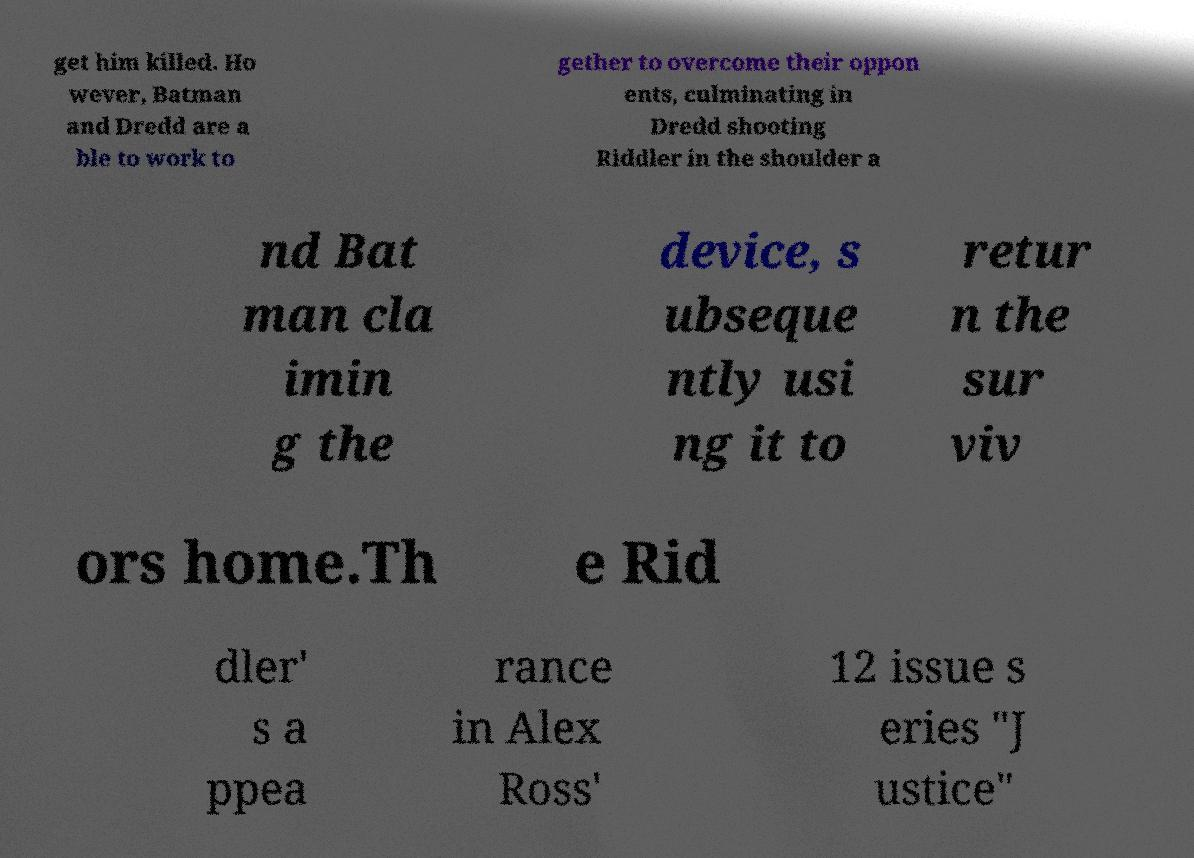Please identify and transcribe the text found in this image. get him killed. Ho wever, Batman and Dredd are a ble to work to gether to overcome their oppon ents, culminating in Dredd shooting Riddler in the shoulder a nd Bat man cla imin g the device, s ubseque ntly usi ng it to retur n the sur viv ors home.Th e Rid dler' s a ppea rance in Alex Ross' 12 issue s eries "J ustice" 